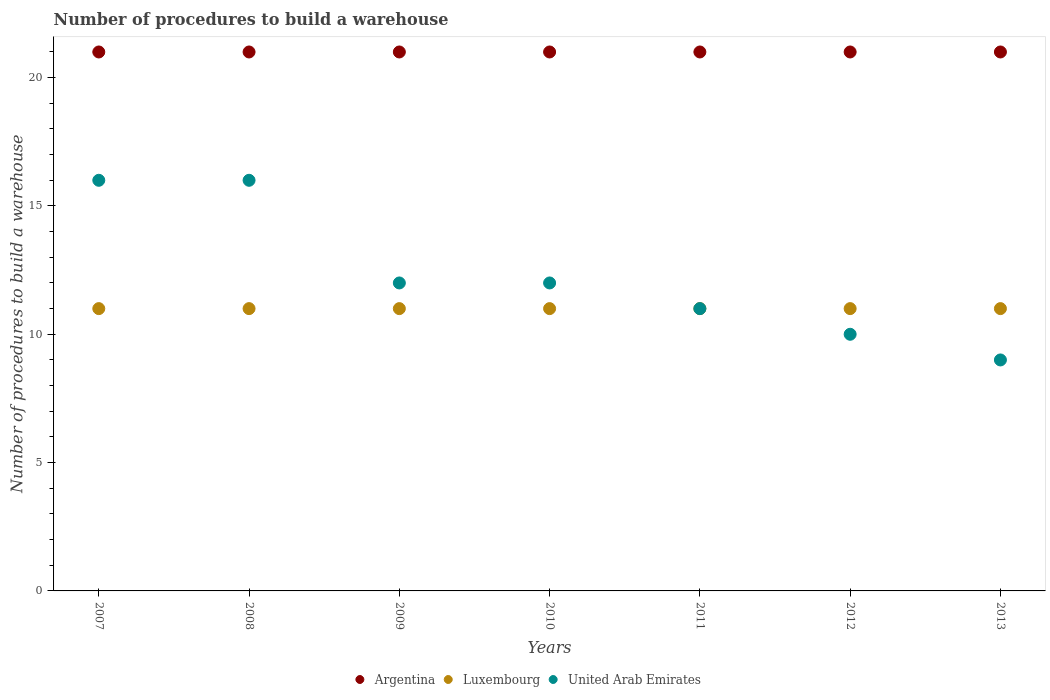What is the number of procedures to build a warehouse in in Argentina in 2009?
Offer a very short reply. 21. Across all years, what is the maximum number of procedures to build a warehouse in in United Arab Emirates?
Your response must be concise. 16. Across all years, what is the minimum number of procedures to build a warehouse in in Luxembourg?
Your answer should be very brief. 11. In which year was the number of procedures to build a warehouse in in United Arab Emirates minimum?
Provide a short and direct response. 2013. What is the total number of procedures to build a warehouse in in United Arab Emirates in the graph?
Offer a terse response. 86. What is the difference between the number of procedures to build a warehouse in in Argentina in 2011 and the number of procedures to build a warehouse in in Luxembourg in 2010?
Your answer should be compact. 10. What is the average number of procedures to build a warehouse in in United Arab Emirates per year?
Your answer should be compact. 12.29. In the year 2013, what is the difference between the number of procedures to build a warehouse in in Luxembourg and number of procedures to build a warehouse in in Argentina?
Your answer should be very brief. -10. In how many years, is the number of procedures to build a warehouse in in Argentina greater than 19?
Offer a terse response. 7. Is the number of procedures to build a warehouse in in Argentina in 2008 less than that in 2010?
Offer a terse response. No. What is the difference between the highest and the second highest number of procedures to build a warehouse in in Luxembourg?
Your answer should be compact. 0. What is the difference between the highest and the lowest number of procedures to build a warehouse in in Argentina?
Offer a very short reply. 0. Does the number of procedures to build a warehouse in in Argentina monotonically increase over the years?
Your answer should be very brief. No. Is the number of procedures to build a warehouse in in United Arab Emirates strictly less than the number of procedures to build a warehouse in in Argentina over the years?
Offer a terse response. Yes. What is the difference between two consecutive major ticks on the Y-axis?
Keep it short and to the point. 5. How are the legend labels stacked?
Make the answer very short. Horizontal. What is the title of the graph?
Your response must be concise. Number of procedures to build a warehouse. Does "Lower middle income" appear as one of the legend labels in the graph?
Your response must be concise. No. What is the label or title of the X-axis?
Your response must be concise. Years. What is the label or title of the Y-axis?
Provide a succinct answer. Number of procedures to build a warehouse. What is the Number of procedures to build a warehouse in Argentina in 2007?
Your response must be concise. 21. What is the Number of procedures to build a warehouse of Luxembourg in 2007?
Your response must be concise. 11. What is the Number of procedures to build a warehouse of Argentina in 2008?
Provide a succinct answer. 21. What is the Number of procedures to build a warehouse of Luxembourg in 2008?
Your response must be concise. 11. What is the Number of procedures to build a warehouse in Argentina in 2009?
Your answer should be compact. 21. What is the Number of procedures to build a warehouse in Luxembourg in 2009?
Provide a short and direct response. 11. What is the Number of procedures to build a warehouse in Argentina in 2010?
Ensure brevity in your answer.  21. What is the Number of procedures to build a warehouse of United Arab Emirates in 2010?
Your answer should be very brief. 12. What is the Number of procedures to build a warehouse in Argentina in 2011?
Ensure brevity in your answer.  21. What is the Number of procedures to build a warehouse in Luxembourg in 2011?
Provide a short and direct response. 11. What is the Number of procedures to build a warehouse of Argentina in 2012?
Offer a terse response. 21. What is the Number of procedures to build a warehouse in United Arab Emirates in 2012?
Provide a short and direct response. 10. What is the Number of procedures to build a warehouse of Argentina in 2013?
Make the answer very short. 21. What is the Number of procedures to build a warehouse of Luxembourg in 2013?
Your response must be concise. 11. Across all years, what is the maximum Number of procedures to build a warehouse of Luxembourg?
Offer a terse response. 11. Across all years, what is the maximum Number of procedures to build a warehouse in United Arab Emirates?
Provide a succinct answer. 16. Across all years, what is the minimum Number of procedures to build a warehouse in Luxembourg?
Offer a very short reply. 11. What is the total Number of procedures to build a warehouse of Argentina in the graph?
Your answer should be compact. 147. What is the total Number of procedures to build a warehouse of United Arab Emirates in the graph?
Ensure brevity in your answer.  86. What is the difference between the Number of procedures to build a warehouse in Luxembourg in 2007 and that in 2008?
Offer a very short reply. 0. What is the difference between the Number of procedures to build a warehouse of Argentina in 2007 and that in 2009?
Provide a succinct answer. 0. What is the difference between the Number of procedures to build a warehouse of Argentina in 2007 and that in 2010?
Your answer should be compact. 0. What is the difference between the Number of procedures to build a warehouse of Luxembourg in 2007 and that in 2010?
Your answer should be compact. 0. What is the difference between the Number of procedures to build a warehouse in United Arab Emirates in 2007 and that in 2010?
Keep it short and to the point. 4. What is the difference between the Number of procedures to build a warehouse of Luxembourg in 2007 and that in 2011?
Make the answer very short. 0. What is the difference between the Number of procedures to build a warehouse in United Arab Emirates in 2007 and that in 2011?
Your answer should be very brief. 5. What is the difference between the Number of procedures to build a warehouse in Luxembourg in 2007 and that in 2012?
Keep it short and to the point. 0. What is the difference between the Number of procedures to build a warehouse in United Arab Emirates in 2007 and that in 2012?
Ensure brevity in your answer.  6. What is the difference between the Number of procedures to build a warehouse of Argentina in 2008 and that in 2009?
Keep it short and to the point. 0. What is the difference between the Number of procedures to build a warehouse of Luxembourg in 2008 and that in 2010?
Your answer should be very brief. 0. What is the difference between the Number of procedures to build a warehouse in Argentina in 2008 and that in 2011?
Provide a succinct answer. 0. What is the difference between the Number of procedures to build a warehouse in Luxembourg in 2008 and that in 2011?
Offer a very short reply. 0. What is the difference between the Number of procedures to build a warehouse of Argentina in 2008 and that in 2012?
Provide a short and direct response. 0. What is the difference between the Number of procedures to build a warehouse of Luxembourg in 2008 and that in 2012?
Your answer should be compact. 0. What is the difference between the Number of procedures to build a warehouse of United Arab Emirates in 2008 and that in 2012?
Your answer should be compact. 6. What is the difference between the Number of procedures to build a warehouse in Argentina in 2008 and that in 2013?
Provide a succinct answer. 0. What is the difference between the Number of procedures to build a warehouse in United Arab Emirates in 2009 and that in 2010?
Offer a terse response. 0. What is the difference between the Number of procedures to build a warehouse in Argentina in 2009 and that in 2011?
Make the answer very short. 0. What is the difference between the Number of procedures to build a warehouse of Luxembourg in 2009 and that in 2011?
Give a very brief answer. 0. What is the difference between the Number of procedures to build a warehouse of United Arab Emirates in 2009 and that in 2011?
Your answer should be very brief. 1. What is the difference between the Number of procedures to build a warehouse in Luxembourg in 2009 and that in 2012?
Your answer should be compact. 0. What is the difference between the Number of procedures to build a warehouse of Argentina in 2009 and that in 2013?
Keep it short and to the point. 0. What is the difference between the Number of procedures to build a warehouse of United Arab Emirates in 2009 and that in 2013?
Your response must be concise. 3. What is the difference between the Number of procedures to build a warehouse in Argentina in 2010 and that in 2011?
Offer a terse response. 0. What is the difference between the Number of procedures to build a warehouse of Luxembourg in 2010 and that in 2011?
Your response must be concise. 0. What is the difference between the Number of procedures to build a warehouse in Argentina in 2010 and that in 2013?
Offer a terse response. 0. What is the difference between the Number of procedures to build a warehouse of United Arab Emirates in 2011 and that in 2012?
Offer a terse response. 1. What is the difference between the Number of procedures to build a warehouse of United Arab Emirates in 2011 and that in 2013?
Your answer should be compact. 2. What is the difference between the Number of procedures to build a warehouse of Argentina in 2012 and that in 2013?
Provide a short and direct response. 0. What is the difference between the Number of procedures to build a warehouse in Luxembourg in 2012 and that in 2013?
Your response must be concise. 0. What is the difference between the Number of procedures to build a warehouse of United Arab Emirates in 2012 and that in 2013?
Offer a very short reply. 1. What is the difference between the Number of procedures to build a warehouse of Argentina in 2007 and the Number of procedures to build a warehouse of Luxembourg in 2008?
Offer a very short reply. 10. What is the difference between the Number of procedures to build a warehouse in Argentina in 2007 and the Number of procedures to build a warehouse in United Arab Emirates in 2008?
Your answer should be compact. 5. What is the difference between the Number of procedures to build a warehouse of Luxembourg in 2007 and the Number of procedures to build a warehouse of United Arab Emirates in 2009?
Ensure brevity in your answer.  -1. What is the difference between the Number of procedures to build a warehouse in Argentina in 2007 and the Number of procedures to build a warehouse in Luxembourg in 2011?
Provide a succinct answer. 10. What is the difference between the Number of procedures to build a warehouse in Luxembourg in 2007 and the Number of procedures to build a warehouse in United Arab Emirates in 2011?
Ensure brevity in your answer.  0. What is the difference between the Number of procedures to build a warehouse in Argentina in 2007 and the Number of procedures to build a warehouse in United Arab Emirates in 2012?
Your answer should be very brief. 11. What is the difference between the Number of procedures to build a warehouse of Luxembourg in 2007 and the Number of procedures to build a warehouse of United Arab Emirates in 2013?
Your answer should be very brief. 2. What is the difference between the Number of procedures to build a warehouse of Argentina in 2008 and the Number of procedures to build a warehouse of United Arab Emirates in 2009?
Your answer should be very brief. 9. What is the difference between the Number of procedures to build a warehouse of Argentina in 2008 and the Number of procedures to build a warehouse of Luxembourg in 2010?
Ensure brevity in your answer.  10. What is the difference between the Number of procedures to build a warehouse of Luxembourg in 2008 and the Number of procedures to build a warehouse of United Arab Emirates in 2010?
Make the answer very short. -1. What is the difference between the Number of procedures to build a warehouse of Luxembourg in 2008 and the Number of procedures to build a warehouse of United Arab Emirates in 2011?
Ensure brevity in your answer.  0. What is the difference between the Number of procedures to build a warehouse in Argentina in 2008 and the Number of procedures to build a warehouse in United Arab Emirates in 2013?
Your response must be concise. 12. What is the difference between the Number of procedures to build a warehouse in Argentina in 2009 and the Number of procedures to build a warehouse in Luxembourg in 2010?
Keep it short and to the point. 10. What is the difference between the Number of procedures to build a warehouse in Argentina in 2009 and the Number of procedures to build a warehouse in United Arab Emirates in 2010?
Make the answer very short. 9. What is the difference between the Number of procedures to build a warehouse of Luxembourg in 2009 and the Number of procedures to build a warehouse of United Arab Emirates in 2011?
Offer a very short reply. 0. What is the difference between the Number of procedures to build a warehouse of Luxembourg in 2009 and the Number of procedures to build a warehouse of United Arab Emirates in 2012?
Offer a very short reply. 1. What is the difference between the Number of procedures to build a warehouse in Argentina in 2009 and the Number of procedures to build a warehouse in Luxembourg in 2013?
Your answer should be very brief. 10. What is the difference between the Number of procedures to build a warehouse in Argentina in 2009 and the Number of procedures to build a warehouse in United Arab Emirates in 2013?
Offer a very short reply. 12. What is the difference between the Number of procedures to build a warehouse of Argentina in 2010 and the Number of procedures to build a warehouse of Luxembourg in 2011?
Provide a succinct answer. 10. What is the difference between the Number of procedures to build a warehouse of Luxembourg in 2010 and the Number of procedures to build a warehouse of United Arab Emirates in 2011?
Make the answer very short. 0. What is the difference between the Number of procedures to build a warehouse in Argentina in 2010 and the Number of procedures to build a warehouse in United Arab Emirates in 2012?
Your answer should be very brief. 11. What is the difference between the Number of procedures to build a warehouse of Luxembourg in 2010 and the Number of procedures to build a warehouse of United Arab Emirates in 2012?
Provide a succinct answer. 1. What is the difference between the Number of procedures to build a warehouse of Luxembourg in 2010 and the Number of procedures to build a warehouse of United Arab Emirates in 2013?
Offer a very short reply. 2. What is the difference between the Number of procedures to build a warehouse of Argentina in 2011 and the Number of procedures to build a warehouse of United Arab Emirates in 2012?
Keep it short and to the point. 11. What is the difference between the Number of procedures to build a warehouse of Argentina in 2011 and the Number of procedures to build a warehouse of Luxembourg in 2013?
Offer a very short reply. 10. What is the difference between the Number of procedures to build a warehouse of Luxembourg in 2011 and the Number of procedures to build a warehouse of United Arab Emirates in 2013?
Your response must be concise. 2. What is the difference between the Number of procedures to build a warehouse of Argentina in 2012 and the Number of procedures to build a warehouse of United Arab Emirates in 2013?
Offer a very short reply. 12. What is the average Number of procedures to build a warehouse in United Arab Emirates per year?
Provide a succinct answer. 12.29. In the year 2007, what is the difference between the Number of procedures to build a warehouse in Argentina and Number of procedures to build a warehouse in United Arab Emirates?
Your answer should be very brief. 5. In the year 2008, what is the difference between the Number of procedures to build a warehouse of Argentina and Number of procedures to build a warehouse of Luxembourg?
Offer a terse response. 10. In the year 2008, what is the difference between the Number of procedures to build a warehouse of Luxembourg and Number of procedures to build a warehouse of United Arab Emirates?
Offer a very short reply. -5. In the year 2009, what is the difference between the Number of procedures to build a warehouse of Luxembourg and Number of procedures to build a warehouse of United Arab Emirates?
Offer a very short reply. -1. In the year 2010, what is the difference between the Number of procedures to build a warehouse in Luxembourg and Number of procedures to build a warehouse in United Arab Emirates?
Make the answer very short. -1. In the year 2012, what is the difference between the Number of procedures to build a warehouse in Argentina and Number of procedures to build a warehouse in United Arab Emirates?
Make the answer very short. 11. In the year 2013, what is the difference between the Number of procedures to build a warehouse of Argentina and Number of procedures to build a warehouse of Luxembourg?
Offer a very short reply. 10. What is the ratio of the Number of procedures to build a warehouse of Argentina in 2007 to that in 2008?
Offer a very short reply. 1. What is the ratio of the Number of procedures to build a warehouse of Argentina in 2007 to that in 2009?
Make the answer very short. 1. What is the ratio of the Number of procedures to build a warehouse in United Arab Emirates in 2007 to that in 2009?
Give a very brief answer. 1.33. What is the ratio of the Number of procedures to build a warehouse in United Arab Emirates in 2007 to that in 2010?
Make the answer very short. 1.33. What is the ratio of the Number of procedures to build a warehouse of Luxembourg in 2007 to that in 2011?
Your answer should be very brief. 1. What is the ratio of the Number of procedures to build a warehouse in United Arab Emirates in 2007 to that in 2011?
Offer a very short reply. 1.45. What is the ratio of the Number of procedures to build a warehouse of Luxembourg in 2007 to that in 2012?
Keep it short and to the point. 1. What is the ratio of the Number of procedures to build a warehouse in United Arab Emirates in 2007 to that in 2012?
Provide a short and direct response. 1.6. What is the ratio of the Number of procedures to build a warehouse in United Arab Emirates in 2007 to that in 2013?
Offer a very short reply. 1.78. What is the ratio of the Number of procedures to build a warehouse of Argentina in 2008 to that in 2009?
Your answer should be compact. 1. What is the ratio of the Number of procedures to build a warehouse in Argentina in 2008 to that in 2011?
Provide a succinct answer. 1. What is the ratio of the Number of procedures to build a warehouse in Luxembourg in 2008 to that in 2011?
Your response must be concise. 1. What is the ratio of the Number of procedures to build a warehouse in United Arab Emirates in 2008 to that in 2011?
Offer a very short reply. 1.45. What is the ratio of the Number of procedures to build a warehouse of Argentina in 2008 to that in 2012?
Provide a short and direct response. 1. What is the ratio of the Number of procedures to build a warehouse of Argentina in 2008 to that in 2013?
Your answer should be very brief. 1. What is the ratio of the Number of procedures to build a warehouse of United Arab Emirates in 2008 to that in 2013?
Provide a succinct answer. 1.78. What is the ratio of the Number of procedures to build a warehouse of United Arab Emirates in 2009 to that in 2010?
Your response must be concise. 1. What is the ratio of the Number of procedures to build a warehouse in United Arab Emirates in 2009 to that in 2011?
Your answer should be very brief. 1.09. What is the ratio of the Number of procedures to build a warehouse of Argentina in 2009 to that in 2012?
Give a very brief answer. 1. What is the ratio of the Number of procedures to build a warehouse of United Arab Emirates in 2009 to that in 2012?
Ensure brevity in your answer.  1.2. What is the ratio of the Number of procedures to build a warehouse of Argentina in 2009 to that in 2013?
Provide a succinct answer. 1. What is the ratio of the Number of procedures to build a warehouse in Argentina in 2010 to that in 2011?
Your response must be concise. 1. What is the ratio of the Number of procedures to build a warehouse of Luxembourg in 2010 to that in 2011?
Provide a succinct answer. 1. What is the ratio of the Number of procedures to build a warehouse of Luxembourg in 2010 to that in 2012?
Provide a short and direct response. 1. What is the ratio of the Number of procedures to build a warehouse in United Arab Emirates in 2010 to that in 2012?
Your answer should be very brief. 1.2. What is the ratio of the Number of procedures to build a warehouse in Argentina in 2010 to that in 2013?
Keep it short and to the point. 1. What is the ratio of the Number of procedures to build a warehouse of Argentina in 2011 to that in 2012?
Your response must be concise. 1. What is the ratio of the Number of procedures to build a warehouse of United Arab Emirates in 2011 to that in 2012?
Your answer should be compact. 1.1. What is the ratio of the Number of procedures to build a warehouse of United Arab Emirates in 2011 to that in 2013?
Ensure brevity in your answer.  1.22. What is the ratio of the Number of procedures to build a warehouse in United Arab Emirates in 2012 to that in 2013?
Your response must be concise. 1.11. What is the difference between the highest and the second highest Number of procedures to build a warehouse of Luxembourg?
Make the answer very short. 0. What is the difference between the highest and the second highest Number of procedures to build a warehouse in United Arab Emirates?
Offer a very short reply. 0. What is the difference between the highest and the lowest Number of procedures to build a warehouse in Argentina?
Offer a terse response. 0. What is the difference between the highest and the lowest Number of procedures to build a warehouse of Luxembourg?
Offer a very short reply. 0. What is the difference between the highest and the lowest Number of procedures to build a warehouse of United Arab Emirates?
Make the answer very short. 7. 